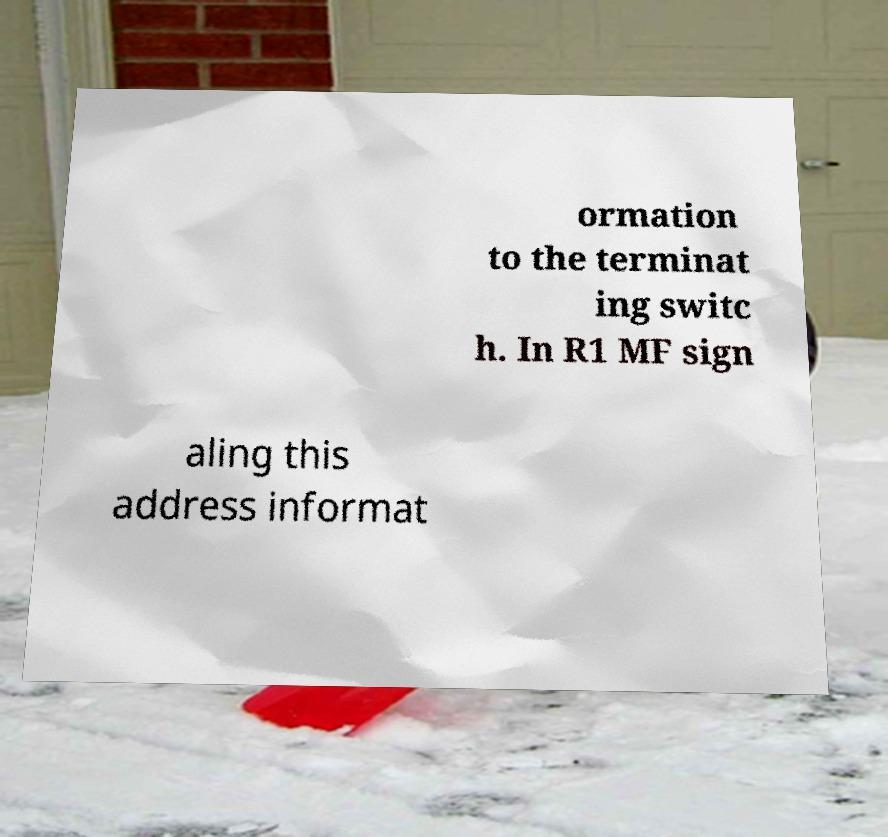There's text embedded in this image that I need extracted. Can you transcribe it verbatim? ormation to the terminat ing switc h. In R1 MF sign aling this address informat 